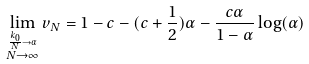Convert formula to latex. <formula><loc_0><loc_0><loc_500><loc_500>\lim _ { \stackrel { \frac { k _ { 0 } } { N } \rightarrow \alpha } { N \rightarrow \infty } } v _ { N } = 1 - c - ( c + \frac { 1 } { 2 } ) \alpha - \frac { c \alpha } { 1 - \alpha } \log ( \alpha )</formula> 